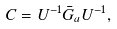<formula> <loc_0><loc_0><loc_500><loc_500>C = U ^ { - 1 } \bar { G } _ { a } U ^ { - 1 } ,</formula> 